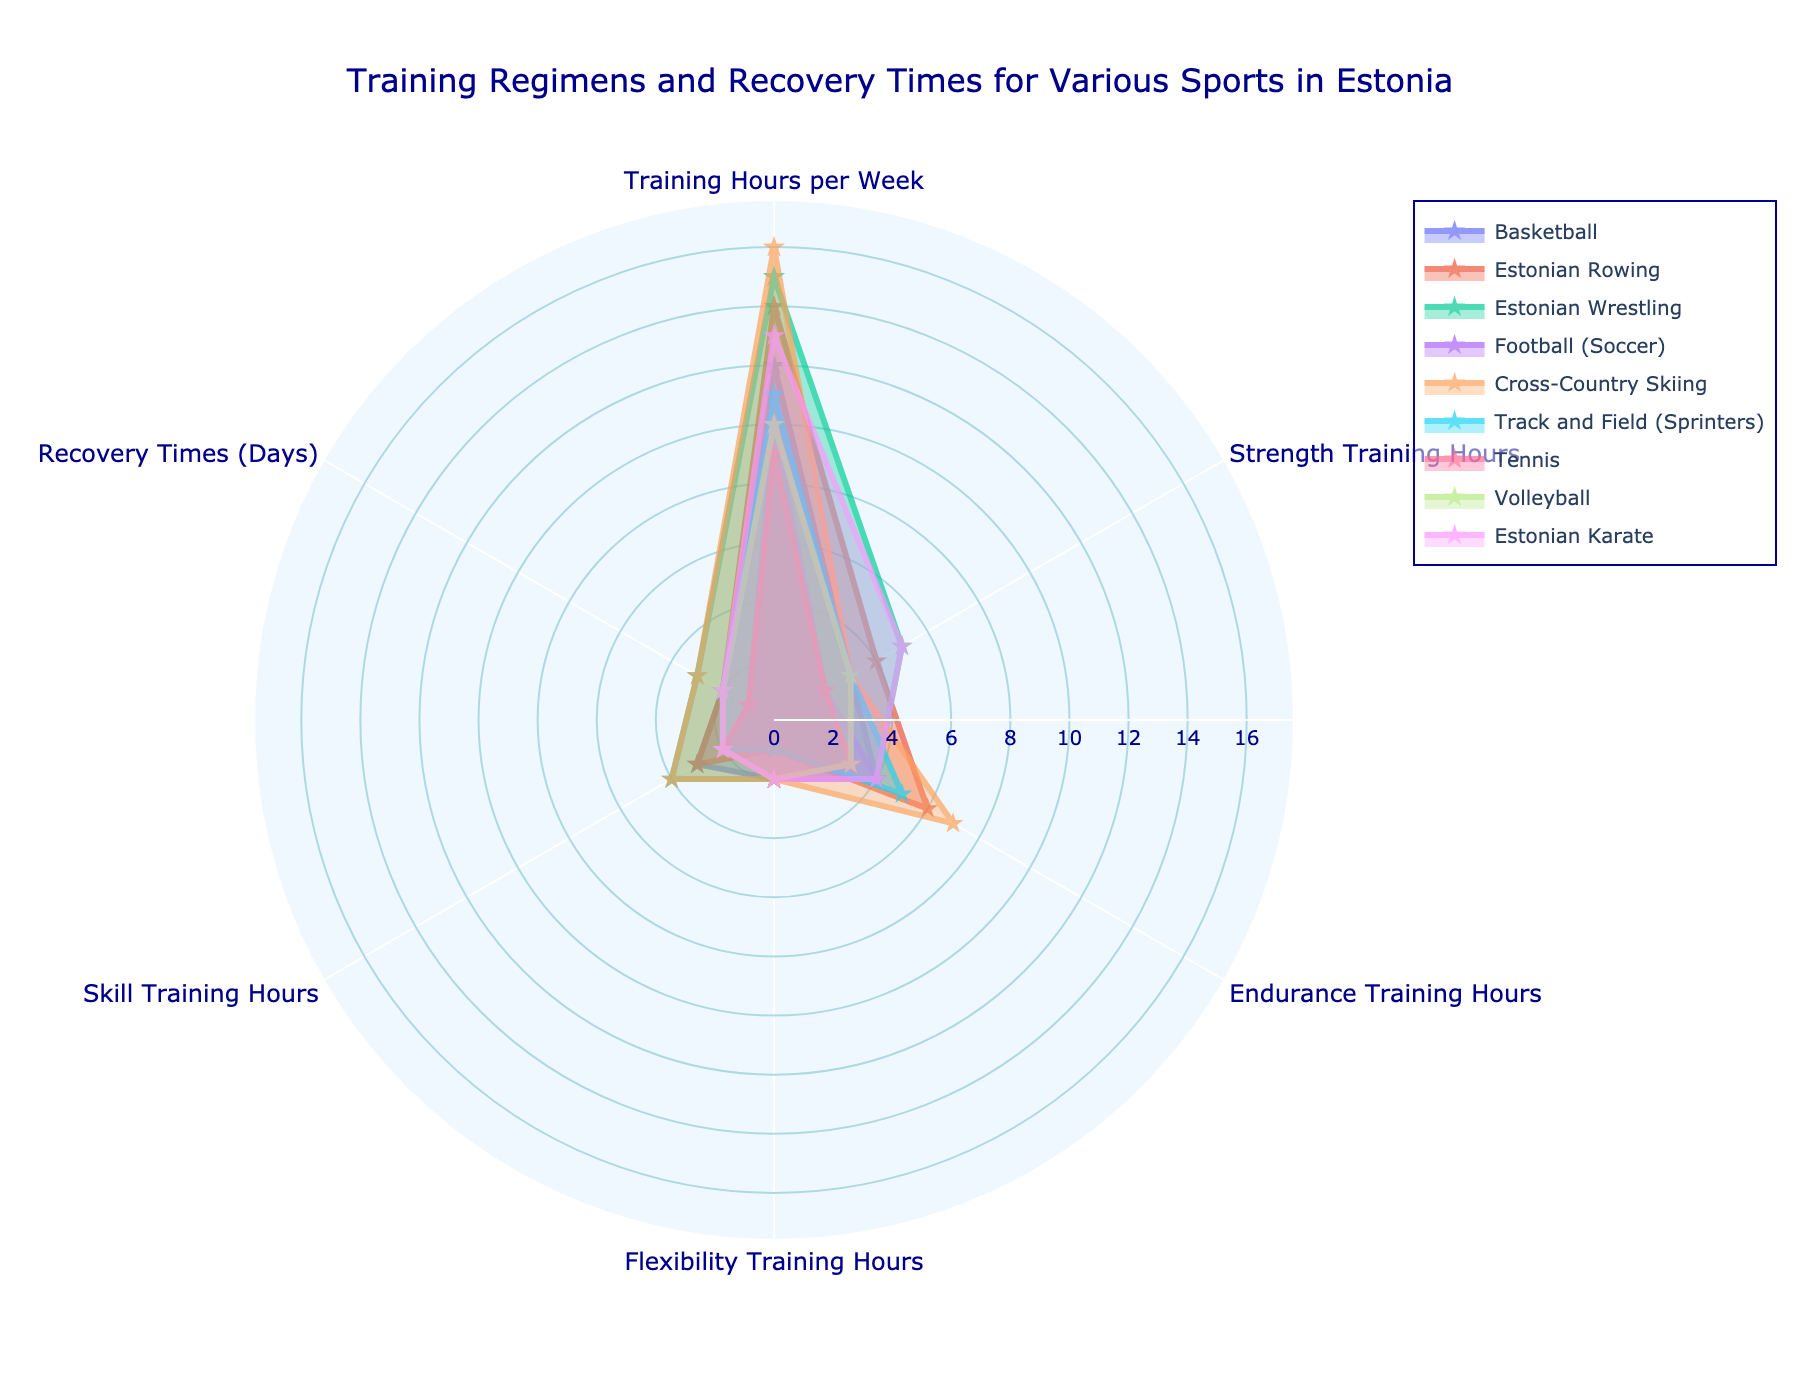What's the total number of training hours per week for Cross-Country Skiing and Football (Soccer)? Cross-Country Skiing has 16 training hours per week and Football (Soccer) has 10. Adding them together, 16 + 10 = 26
Answer: 26 Which sport has the highest number of strength training hours? By inspecting the Strength Training Hours category, Estonian Wrestling has the highest with 5 hours
Answer: Estonian Wrestling How many sports have flexibility training hours greater than 1? Count the sports with Flexibility Training Hours above 1: Basketball, Estonian Wrestling, Football (Soccer), Cross-Country Skiing, Tennis, Volleyball, Estonian Karate (7 sports)
Answer: 7 What is the median recovery time (days) for all the sports listed? List the recovery times: 2, 2, 3, 1, 3, 2, 1, 2, 2. Sorting them gives: 1, 1, 2, 2, 2, 2, 2, 3, 3. The middle value (fifth value) is 2
Answer: 2 Which sport has the least skill training hours? By inspecting the Skill Training Hours category, Football (Soccer) and Tennis both have the least with 2 hours
Answer: Football (Soccer), Tennis Between Estonian Rowing and Volleyball, which sport dedicates more time to endurance training? Estonian Rowing has 6 hours of endurance training, while Volleyball has 3. Estonian Rowing spends more time on endurance training
Answer: Estonian Rowing What's the average number of training hours per week across all sports? Sum all training hours per week: 12 + 14 + 15 + 10 + 16 + 11 + 9 + 10 + 13 = 110. There are 9 sports, so average is 110 / 9 ≈ 12.22
Answer: 12.22 Which sport has a higher ratio of strength training to total training hours: Basketball or Tennis? Basketball has 3/12 = 0.25, Tennis has 2/9 ≈ 0.22. Basketball has a higher ratio
Answer: Basketball Does Estonian Karate have more or less recovery time compared to the average recovery time for all sports? Average recovery time is 2. Estonian Karate has 2 days, which is the same as the average
Answer: Same 